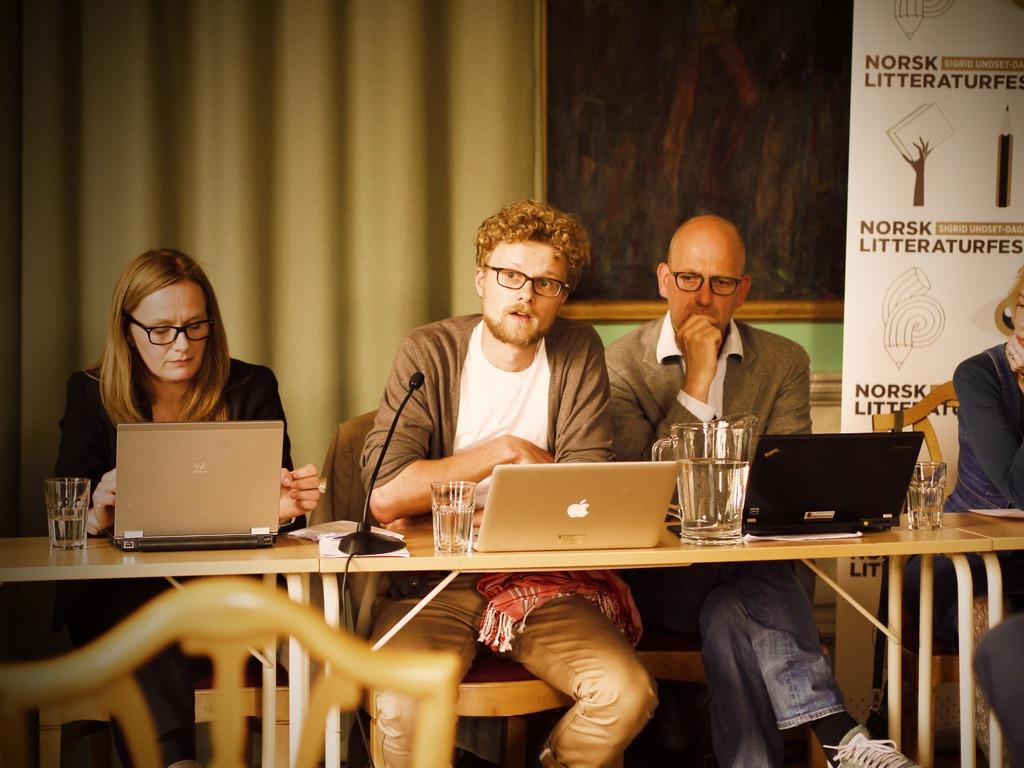What are the people in the image doing? The people are sitting on chairs. What is on the table in the image? There is a laptop and a microphone on the table. What can be seen in the background of the image? The background includes a curtain and a name board. What type of government is being discussed in the image? There is no discussion of government in the image; it only shows people sitting on chairs, a table with a laptop and microphone, and a background with a curtain and name board. 